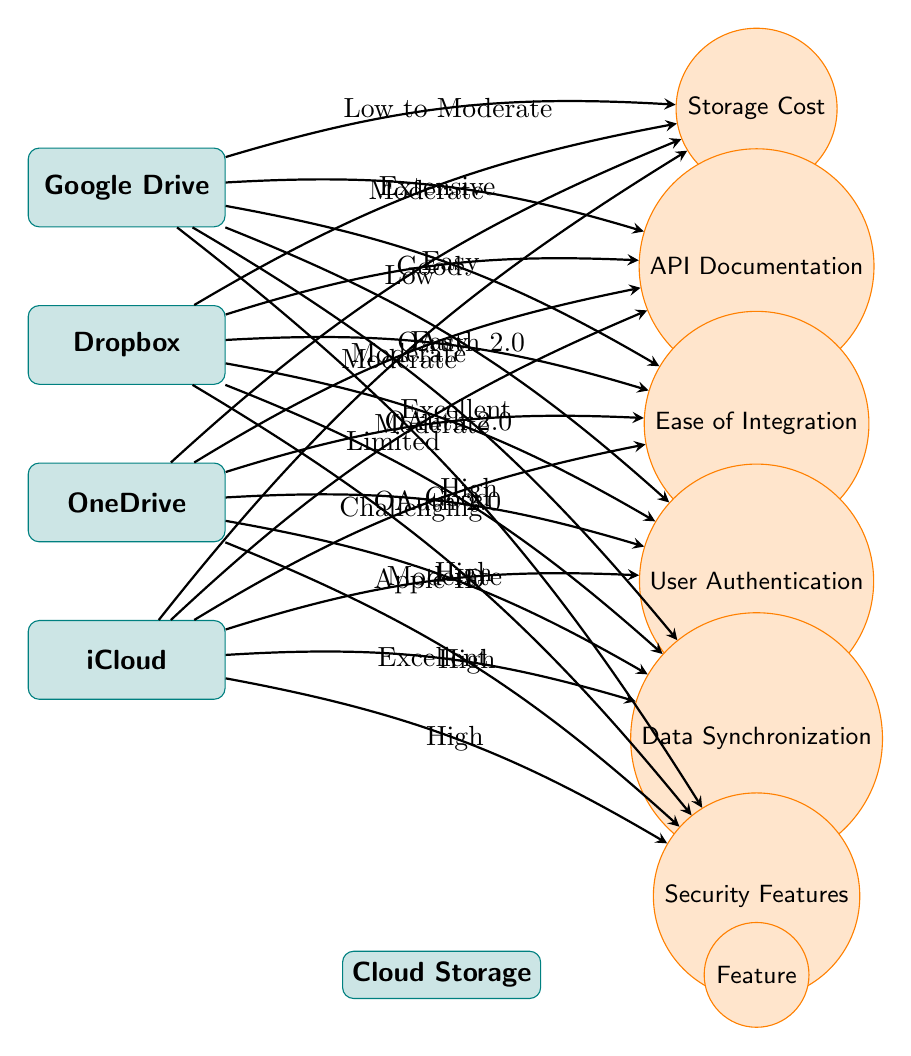What is the storage cost for Google Drive? The diagram indicates that the storage cost for Google Drive is categorized as "Low to Moderate." This is identified by looking at the edge connected from the Google Drive node to the Storage Cost feature.
Answer: Low to Moderate Which cloud storage solution has the easiest integration? Both Google Drive and Dropbox are labeled as having "Easy" integration. To determine the answer, we look at the edges connecting the storage solutions to the Ease of Integration feature, and both have the same label.
Answer: Google Drive and Dropbox How would you describe the data synchronization capabilities of OneDrive? According to the diagram, the edge connecting OneDrive to the Data Synchronization feature describes it as "Moderate." We identify this by examining the edge connected from the OneDrive node to the sync feature.
Answer: Moderate What type of user authentication does iCloud use? The diagram specifies that iCloud utilizes "Apple ID" for user authentication. This can be confirmed by the edge connecting the iCloud node to the User Authentication feature.
Answer: Apple ID Which cloud storage solution provides excellent data synchronization? The diagram shows that both Google Drive and iCloud have edges leading to the Data Synchronization feature that are labeled as "Excellent." To answer this, we look for storage solutions connected with "Excellent" edges.
Answer: Google Drive and iCloud Which solution has the most extensive API documentation? Google Drive is identified as having "Extensive" API documentation. This is deduced from the edge between the Google Drive node and the API Documentation feature indicating its quality level.
Answer: Extensive What is the security rating for Dropbox? The diagram indicates that the security rating for Dropbox is "High." This conclusion is reached by examining the edge connecting Dropbox with the Security Features node.
Answer: High How do the storage costs of iCloud and Dropbox compare? Both iCloud and Dropbox are marked as having "Moderate" storage costs. To answer, we observe the edges linking these two solutions to the Storage Cost feature, which both share the same label.
Answer: Moderate What is the integration ease for OneDrive? OneDrive is labeled as having "Moderate" ease of integration, as per the inscription along the edge that connects it to the Ease of Integration feature.
Answer: Moderate 